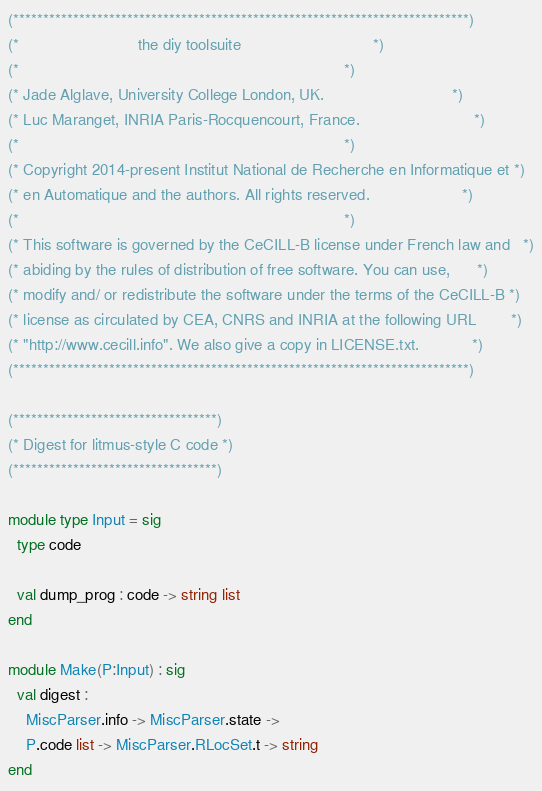<code> <loc_0><loc_0><loc_500><loc_500><_OCaml_>(****************************************************************************)
(*                           the diy toolsuite                              *)
(*                                                                          *)
(* Jade Alglave, University College London, UK.                             *)
(* Luc Maranget, INRIA Paris-Rocquencourt, France.                          *)
(*                                                                          *)
(* Copyright 2014-present Institut National de Recherche en Informatique et *)
(* en Automatique and the authors. All rights reserved.                     *)
(*                                                                          *)
(* This software is governed by the CeCILL-B license under French law and   *)
(* abiding by the rules of distribution of free software. You can use,      *)
(* modify and/ or redistribute the software under the terms of the CeCILL-B *)
(* license as circulated by CEA, CNRS and INRIA at the following URL        *)
(* "http://www.cecill.info". We also give a copy in LICENSE.txt.            *)
(****************************************************************************)

(**********************************)
(* Digest for litmus-style C code *)
(**********************************)

module type Input = sig
  type code

  val dump_prog : code -> string list
end

module Make(P:Input) : sig
  val digest :
    MiscParser.info -> MiscParser.state ->
    P.code list -> MiscParser.RLocSet.t -> string
end
</code> 